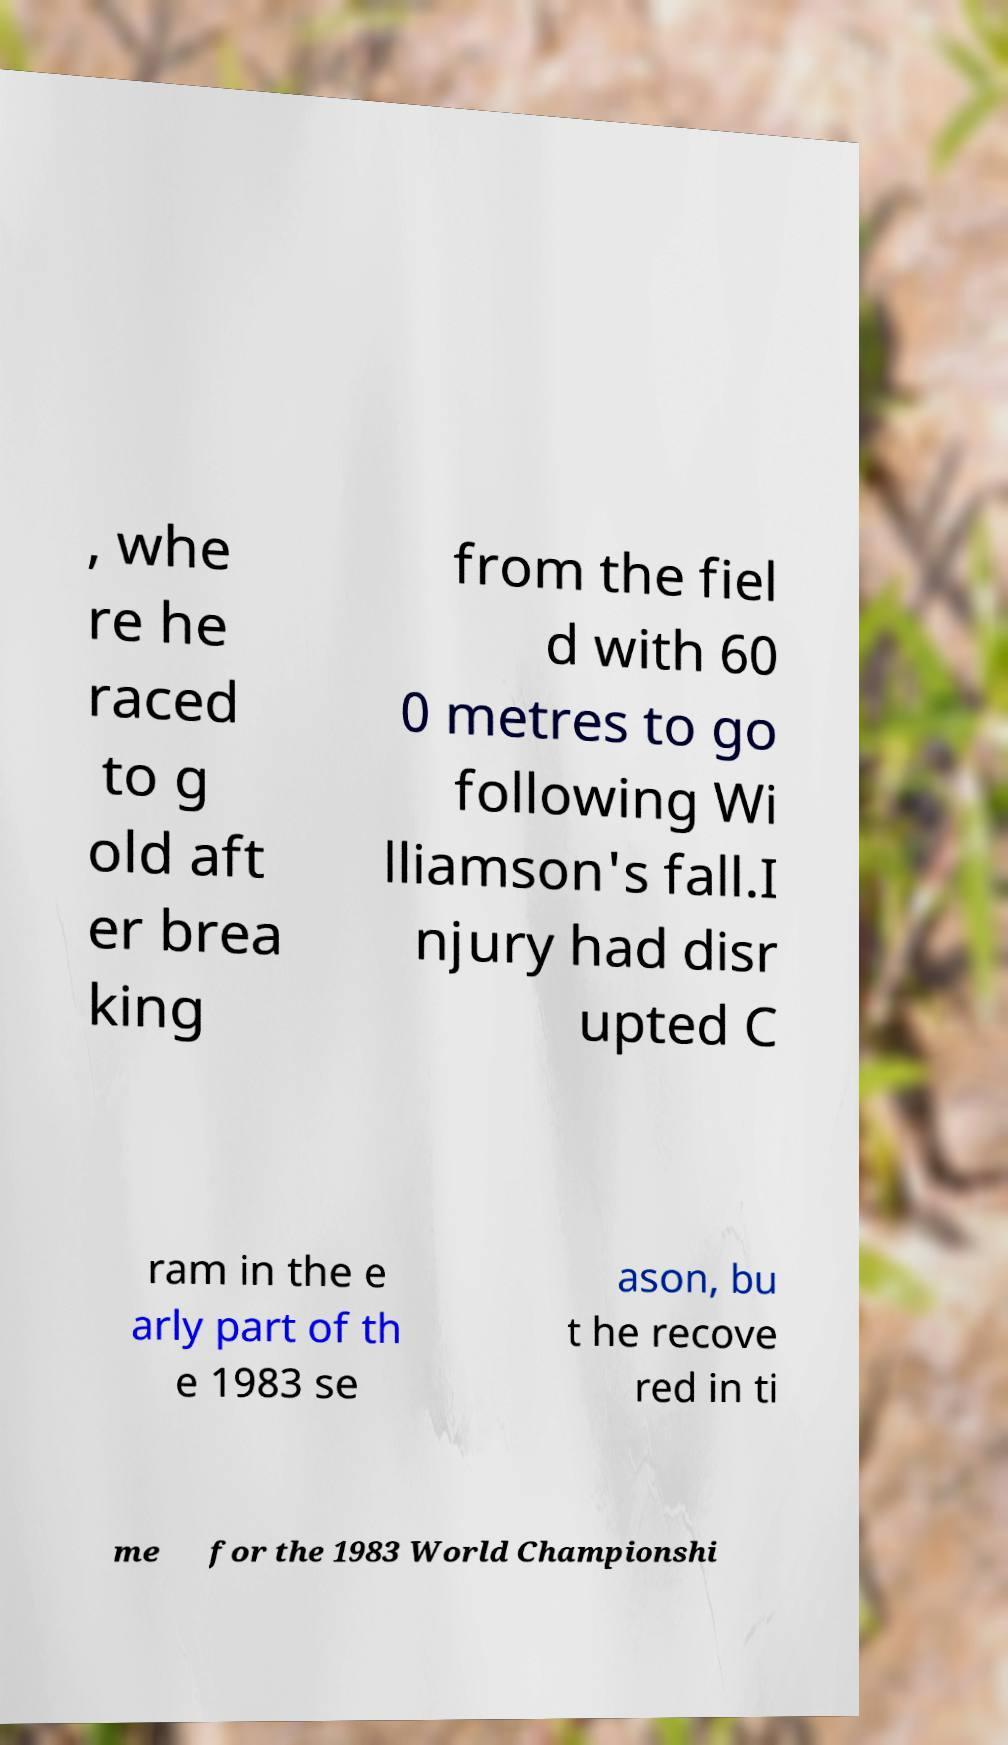What messages or text are displayed in this image? I need them in a readable, typed format. , whe re he raced to g old aft er brea king from the fiel d with 60 0 metres to go following Wi lliamson's fall.I njury had disr upted C ram in the e arly part of th e 1983 se ason, bu t he recove red in ti me for the 1983 World Championshi 